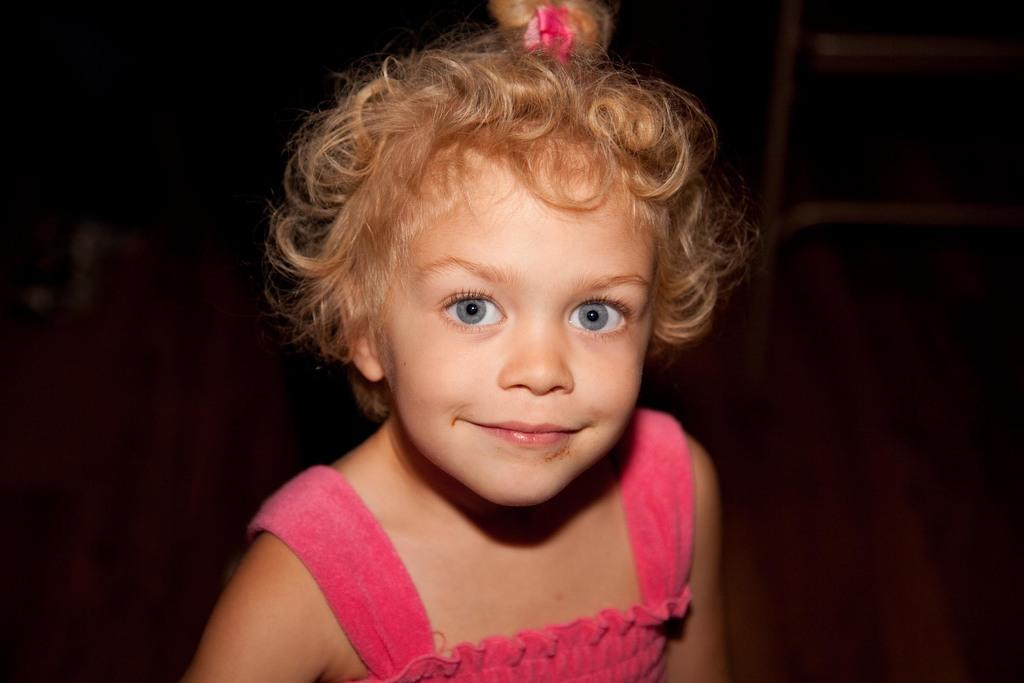Who is the main subject in the image? There is a girl in the image. What is the girl doing in the image? The girl is smiling in the image. What color is the girl's dress? The girl is wearing a pink dress. What accessory is the girl wearing in her hair? The girl has a pink hair ribbon. What type of tank can be seen in the image? There is no tank present in the image; it features a girl wearing a pink dress and a pink hair ribbon. How many dolls are visible in the image? There are no dolls present in the image. 